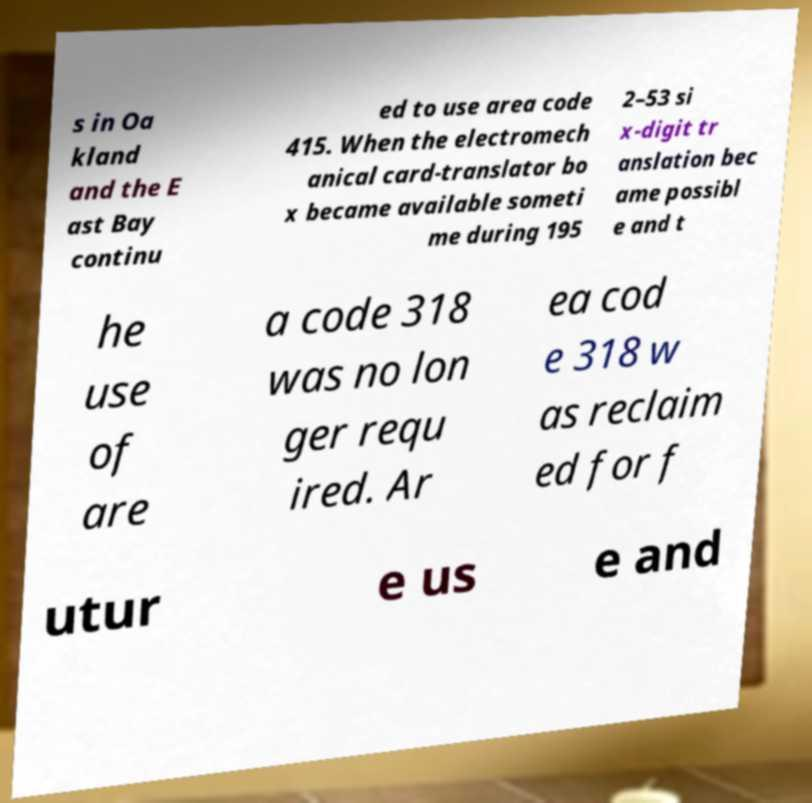Can you accurately transcribe the text from the provided image for me? s in Oa kland and the E ast Bay continu ed to use area code 415. When the electromech anical card-translator bo x became available someti me during 195 2–53 si x-digit tr anslation bec ame possibl e and t he use of are a code 318 was no lon ger requ ired. Ar ea cod e 318 w as reclaim ed for f utur e us e and 